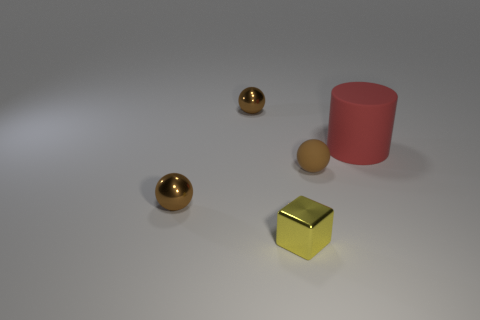Subtract all brown spheres. How many were subtracted if there are1brown spheres left? 2 Add 3 big matte cylinders. How many objects exist? 8 Subtract all blocks. How many objects are left? 4 Add 4 tiny brown metal things. How many tiny brown metal things are left? 6 Add 4 brown shiny balls. How many brown shiny balls exist? 6 Subtract 0 brown cylinders. How many objects are left? 5 Subtract all red matte things. Subtract all yellow cylinders. How many objects are left? 4 